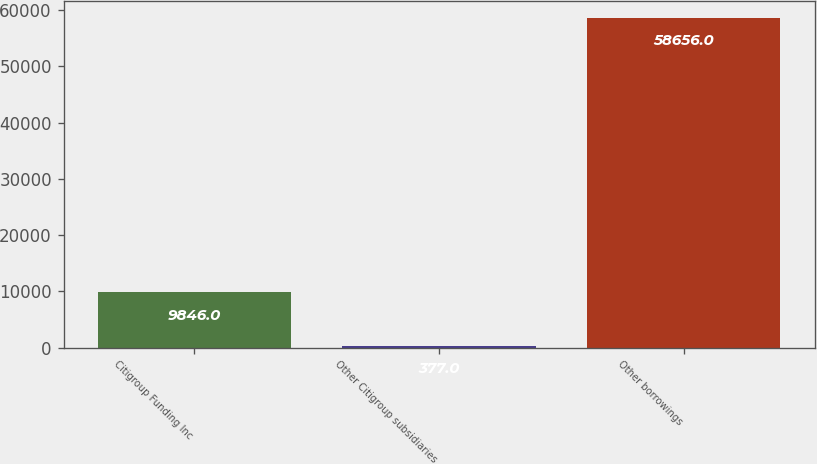Convert chart. <chart><loc_0><loc_0><loc_500><loc_500><bar_chart><fcel>Citigroup Funding Inc<fcel>Other Citigroup subsidiaries<fcel>Other borrowings<nl><fcel>9846<fcel>377<fcel>58656<nl></chart> 